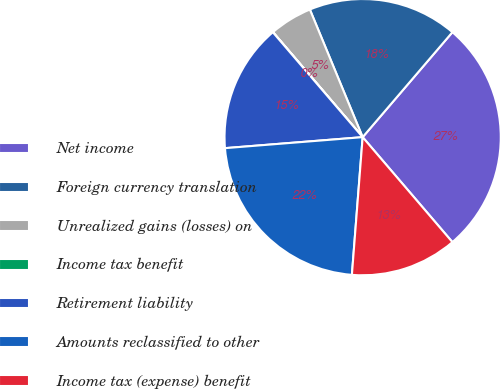Convert chart. <chart><loc_0><loc_0><loc_500><loc_500><pie_chart><fcel>Net income<fcel>Foreign currency translation<fcel>Unrealized gains (losses) on<fcel>Income tax benefit<fcel>Retirement liability<fcel>Amounts reclassified to other<fcel>Income tax (expense) benefit<nl><fcel>27.48%<fcel>17.5%<fcel>5.01%<fcel>0.02%<fcel>15.0%<fcel>22.49%<fcel>12.5%<nl></chart> 